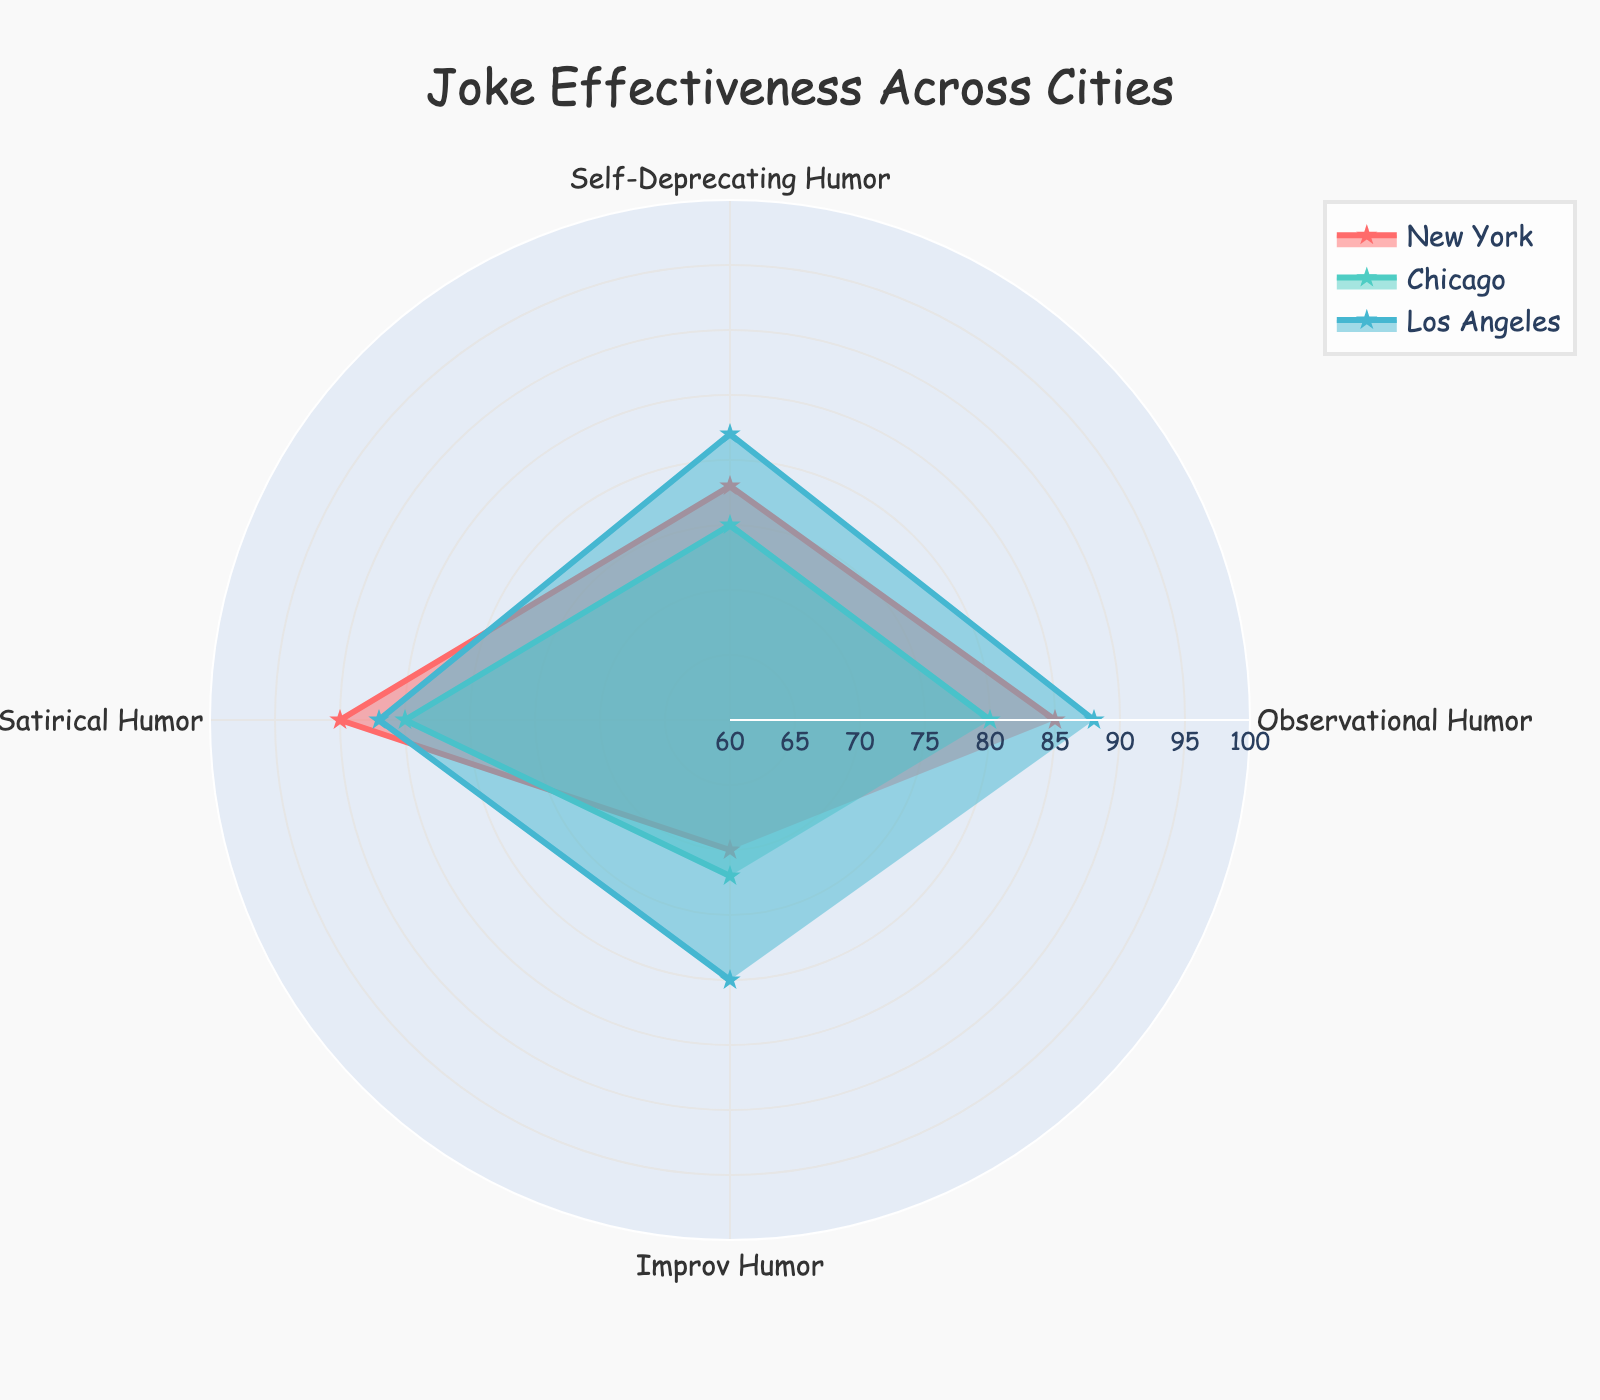Which city had the highest effectiveness in Observational Humor? The maximum value among the cities for Observational Humor can be obtained directly from the chart. New York has a value of 85, Chicago has 80, and Los Angeles has 88. Therefore, Los Angeles has the highest effectiveness.
Answer: Los Angeles What is the average effectiveness of Improv Humor across New York, Chicago, and Los Angeles? To find the average effectiveness, sum the Improv Humor values for the three cities and divide by 3. New York has 70, Chicago has 72, and Los Angeles has 80. (70 + 72 + 80) / 3 = 74
Answer: 74 Which joke category has the smallest range of effectiveness values across New York, Chicago, and Los Angeles? To find the smallest range, calculate the range (max - min) for each joke category and compare. Observational Humor: 88 (LA) - 80 (Chicago) = 8. Self-Deprecating Humor: 82 (LA) - 75 (Chicago) = 7. Satirical Humor: 90 (NY) - 85 (Chicago) = 5. Improv Humor: 80 (LA) - 70 (NY) = 10. Satirical Humor has the smallest range of 5.
Answer: Satirical Humor Which city shows the most consistency (smallest range) in the effectiveness across all joke categories? For each city, calculate the range of effectiveness values across all joke categories. New York: 90 - 70 = 20. Chicago: 85 - 72 = 13. Los Angeles: 88 - 80 = 8. Los Angeles shows the smallest range of 8.
Answer: Los Angeles How does Self-Deprecating Humor compare between New York and Chicago? Compare the effectiveness values for Self-Deprecating Humor in New York (78) and Chicago (75). New York has a higher effectiveness than Chicago.
Answer: New York is higher In which category does New York outperform Los Angeles? Compare the categories one by one for New York and Los Angeles. New York (85) loses to Los Angeles (88) in Observational Humor. New York (78) loses to Los Angeles (82) in Self-Deprecating Humor. New York (90) beats Los Angeles (87) in Satirical Humor. New York (70) loses to Los Angeles (80) in Improv Humor. New York outperforms Los Angeles in Satirical Humor.
Answer: Satirical Humor What is the combined effectiveness of Observational Humor and Satirical Humor in New York? Sum the effectiveness values for Observational Humor and Satirical Humor in New York. Observational Humor: 85, Satirical Humor: 90. 85 + 90 = 175
Answer: 175 